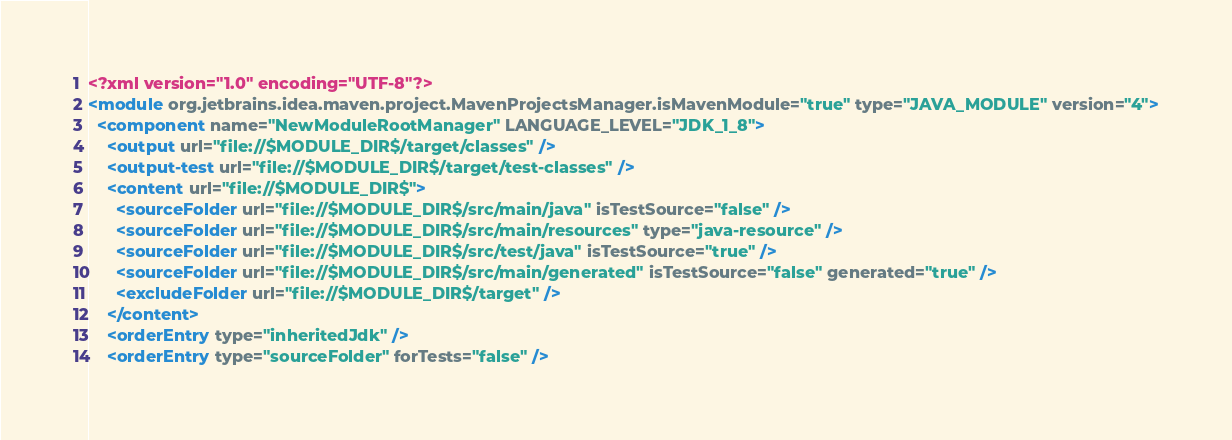<code> <loc_0><loc_0><loc_500><loc_500><_XML_><?xml version="1.0" encoding="UTF-8"?>
<module org.jetbrains.idea.maven.project.MavenProjectsManager.isMavenModule="true" type="JAVA_MODULE" version="4">
  <component name="NewModuleRootManager" LANGUAGE_LEVEL="JDK_1_8">
    <output url="file://$MODULE_DIR$/target/classes" />
    <output-test url="file://$MODULE_DIR$/target/test-classes" />
    <content url="file://$MODULE_DIR$">
      <sourceFolder url="file://$MODULE_DIR$/src/main/java" isTestSource="false" />
      <sourceFolder url="file://$MODULE_DIR$/src/main/resources" type="java-resource" />
      <sourceFolder url="file://$MODULE_DIR$/src/test/java" isTestSource="true" />
      <sourceFolder url="file://$MODULE_DIR$/src/main/generated" isTestSource="false" generated="true" />
      <excludeFolder url="file://$MODULE_DIR$/target" />
    </content>
    <orderEntry type="inheritedJdk" />
    <orderEntry type="sourceFolder" forTests="false" /></code> 